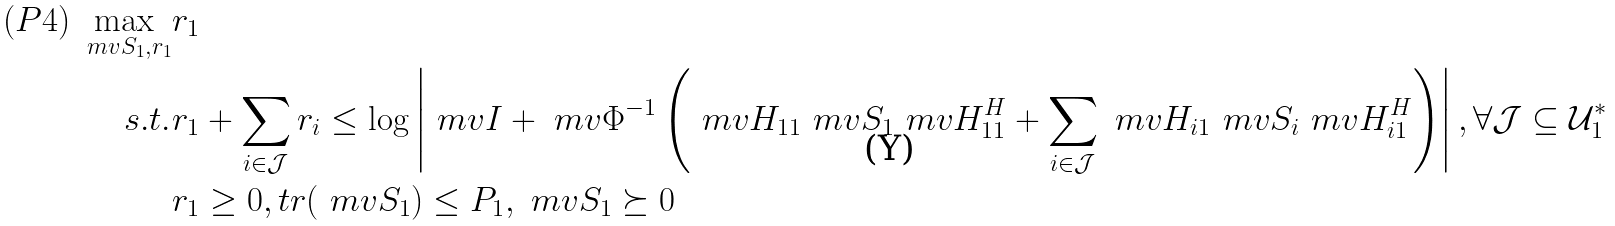Convert formula to latex. <formula><loc_0><loc_0><loc_500><loc_500>( P 4 ) \max _ { \ m v { S } _ { 1 } , r _ { 1 } } & r _ { 1 } \\ s . t . & r _ { 1 } + \sum _ { i \in \mathcal { J } } r _ { i } \leq \log \left | \ m v { I } + \ m v { \Phi } ^ { - 1 } \left ( \ m v { H } _ { 1 1 } \ m v { S } _ { 1 } \ m v { H } _ { 1 1 } ^ { H } + \sum _ { i \in \mathcal { J } } \ m v { H } _ { i 1 } \ m v { S } _ { i } \ m v { H } _ { i 1 } ^ { H } \right ) \right | , \forall \mathcal { J } \subseteq \mathcal { U } _ { 1 } ^ { * } \\ & r _ { 1 } \geq 0 , t r ( \ m v { S } _ { 1 } ) \leq P _ { 1 } , \ m v { S } _ { 1 } \succeq 0</formula> 